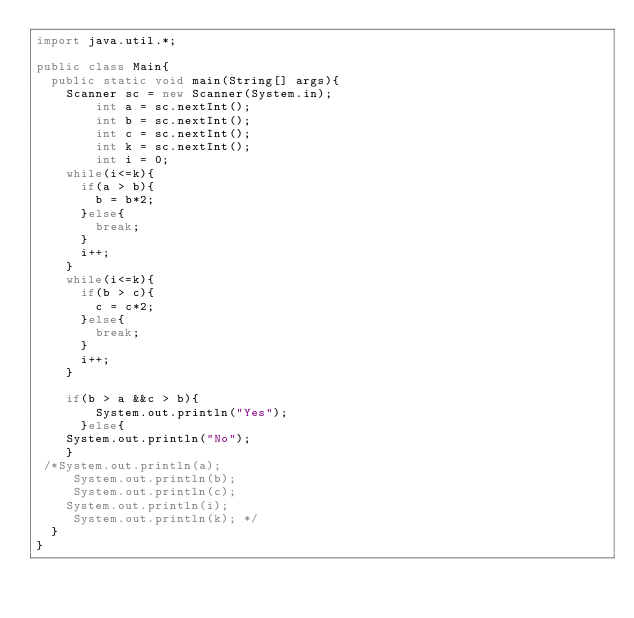<code> <loc_0><loc_0><loc_500><loc_500><_Java_>import java.util.*;
 
public class Main{
  public static void main(String[] args){
    Scanner sc = new Scanner(System.in);
        int a = sc.nextInt();
        int b = sc.nextInt();
    	int c = sc.nextInt();
    	int k = sc.nextInt();
    	int i = 0;
    while(i<=k){
      if(a > b){
        b = b*2;
      }else{
        break;
      }
      i++;
    }
    while(i<=k){
      if(b > c){
        c = c*2;
      }else{
        break;
      }
      i++;
    }
   
    if(b > a &&c > b){
		System.out.println("Yes");
      }else{
    System.out.println("No");
    }
 /*System.out.println(a);
     System.out.println(b);
     System.out.println(c);
    System.out.println(i);
     System.out.println(k); */
  }
}</code> 